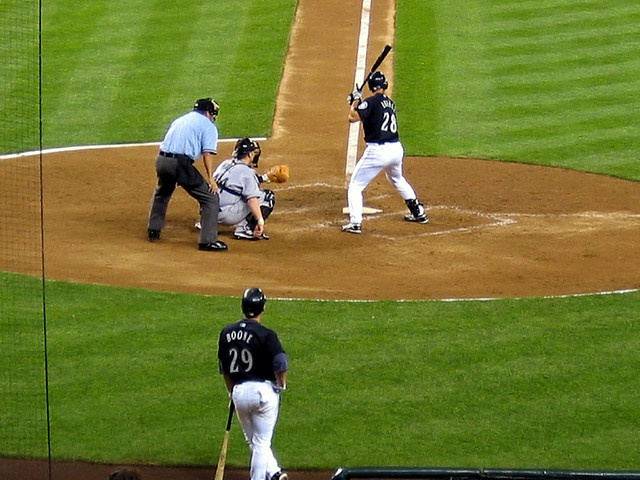Describe the objects in this image and their specific colors. I can see people in olive, black, lavender, gray, and darkgray tones, people in olive, black, lightblue, gray, and lavender tones, people in olive, white, black, darkgray, and gray tones, people in olive, black, lightgray, darkgray, and gray tones, and baseball bat in olive and black tones in this image. 